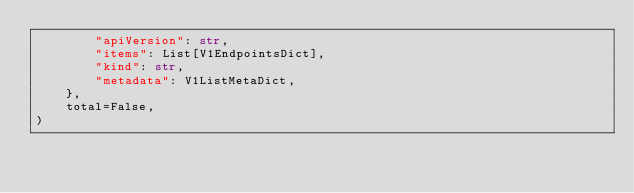<code> <loc_0><loc_0><loc_500><loc_500><_Python_>        "apiVersion": str,
        "items": List[V1EndpointsDict],
        "kind": str,
        "metadata": V1ListMetaDict,
    },
    total=False,
)
</code> 